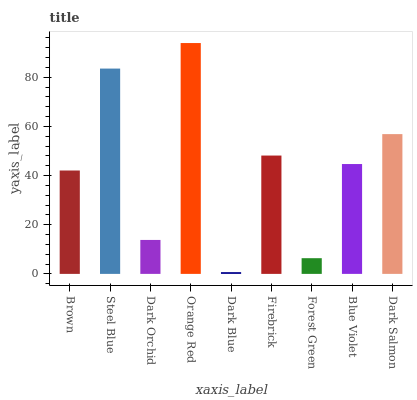Is Dark Blue the minimum?
Answer yes or no. Yes. Is Orange Red the maximum?
Answer yes or no. Yes. Is Steel Blue the minimum?
Answer yes or no. No. Is Steel Blue the maximum?
Answer yes or no. No. Is Steel Blue greater than Brown?
Answer yes or no. Yes. Is Brown less than Steel Blue?
Answer yes or no. Yes. Is Brown greater than Steel Blue?
Answer yes or no. No. Is Steel Blue less than Brown?
Answer yes or no. No. Is Blue Violet the high median?
Answer yes or no. Yes. Is Blue Violet the low median?
Answer yes or no. Yes. Is Brown the high median?
Answer yes or no. No. Is Forest Green the low median?
Answer yes or no. No. 